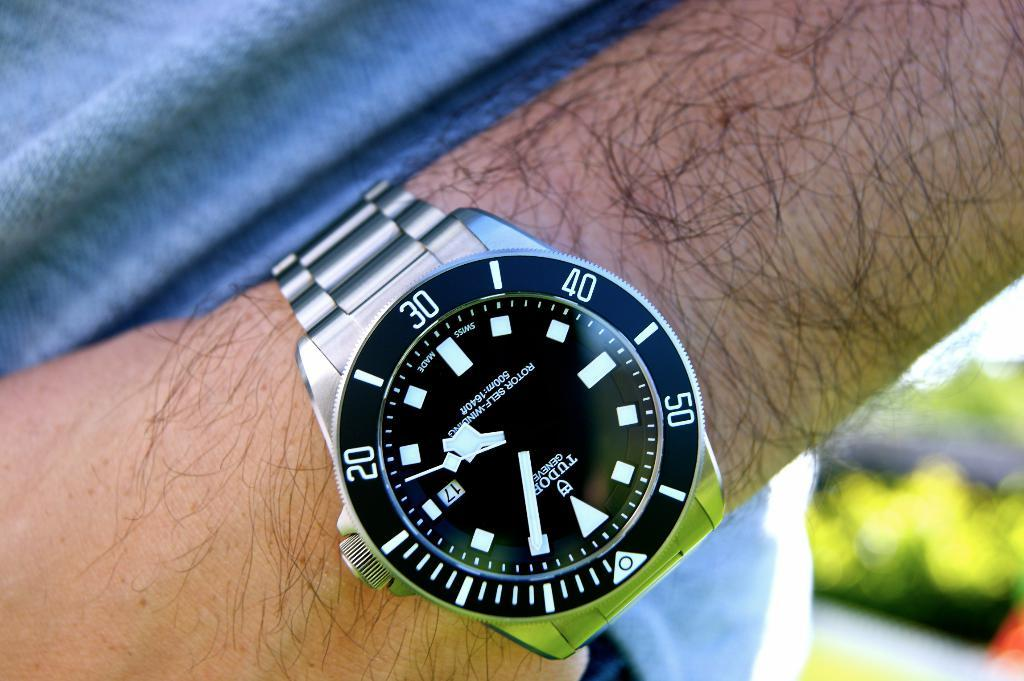Provide a one-sentence caption for the provided image. A Tudor Geneva watch on a hairy man's wrist. 